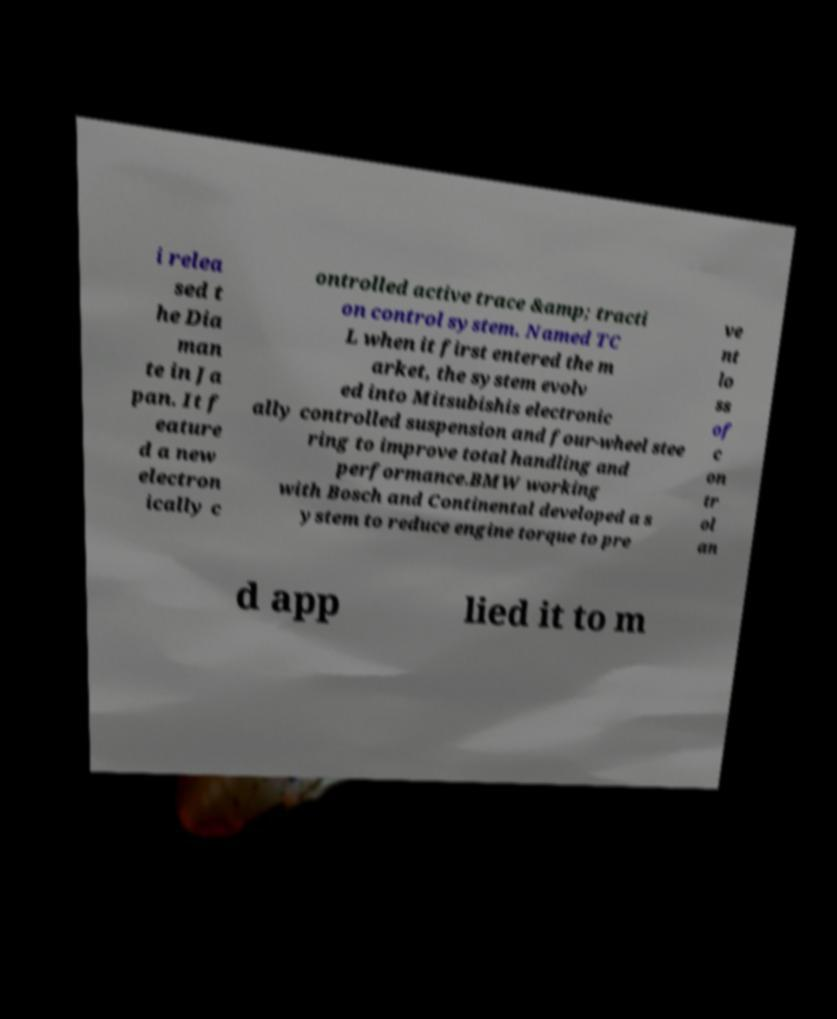Please identify and transcribe the text found in this image. i relea sed t he Dia man te in Ja pan. It f eature d a new electron ically c ontrolled active trace &amp; tracti on control system. Named TC L when it first entered the m arket, the system evolv ed into Mitsubishis electronic ally controlled suspension and four-wheel stee ring to improve total handling and performance.BMW working with Bosch and Continental developed a s ystem to reduce engine torque to pre ve nt lo ss of c on tr ol an d app lied it to m 